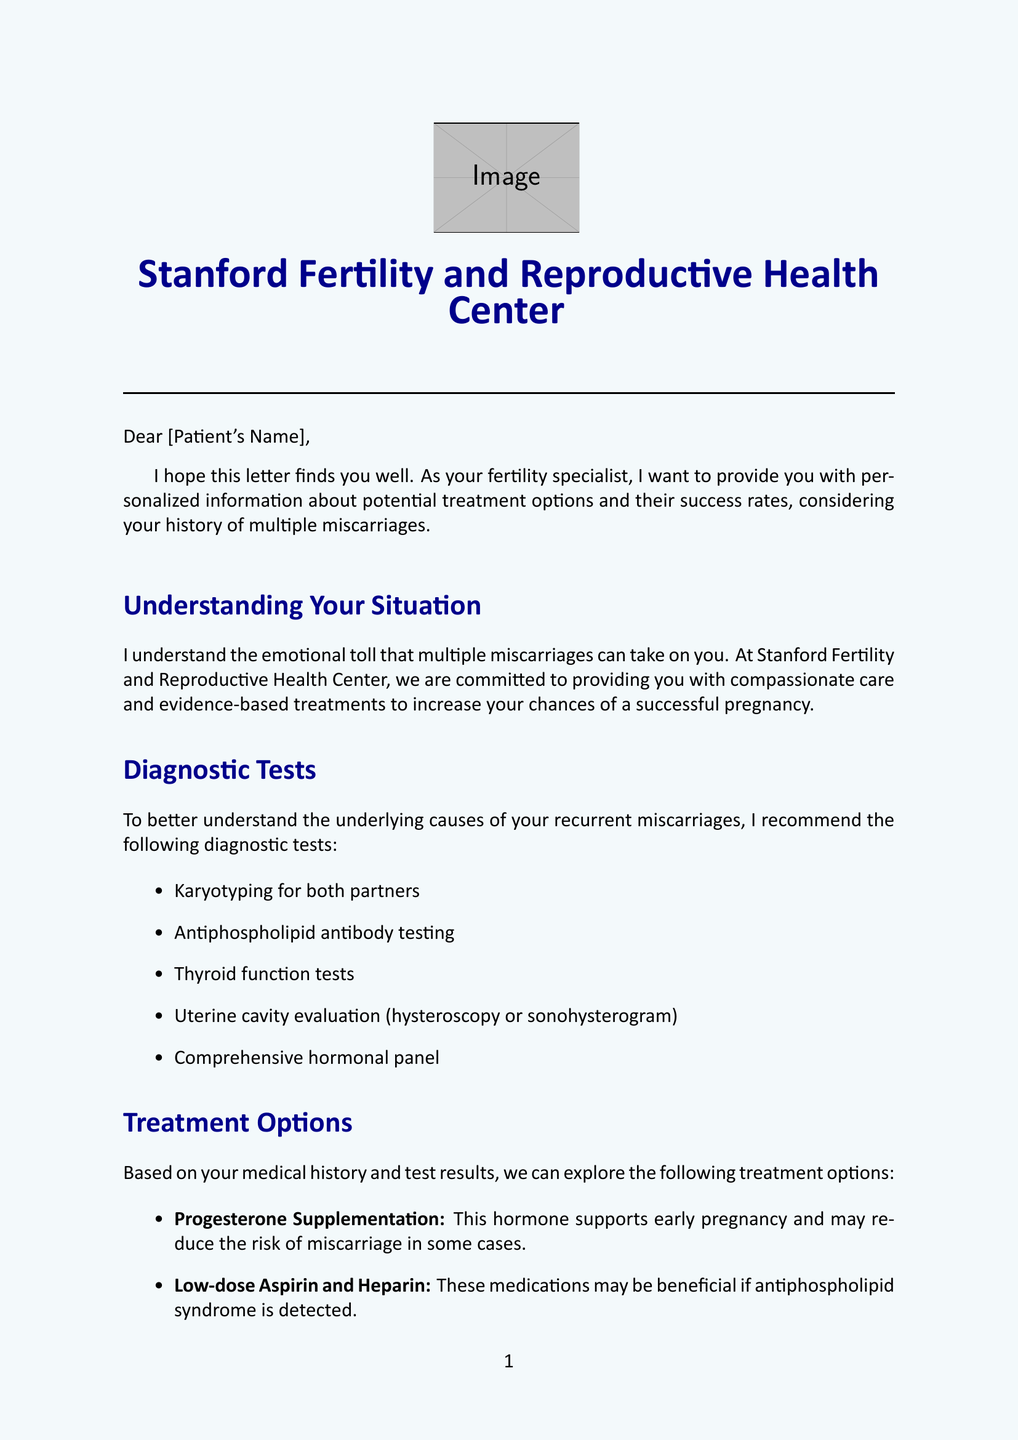what is the name of the clinic? The name of the clinic is mentioned in the letter heading and the closing.
Answer: Stanford Fertility and Reproductive Health Center who is the specialist writing the letter? The name of the specialist is mentioned in the closing of the letter.
Answer: Dr. [Specialist's Name] what is the recommended test for both partners? The letter lists various diagnostic tests and mentions this specific test for both partners.
Answer: Karyotyping what medication may reduce the risk of miscarriage? The letter details a specific hormone that supports early pregnancy.
Answer: Progesterone Supplementation what percentage increase in live birth rates does progesterone supplementation provide? The letter states the increase in live birth rates associated with this treatment.
Answer: 5-10% which service is provided for emotional support? The letter highlights various resources available for emotional support throughout the treatment journey.
Answer: RESOLVE support groups how many patients with recurrent miscarriage successfully get pregnant with appropriate treatment? The document provides a statistic about success rates for women with recurrent miscarriage.
Answer: 65-75% what is suggested as the next step in the process? The letter outlines the next course of action for the patient.
Answer: Schedule a follow-up appointment who specializes in fertility-related stress management? The letter mentions the psychologist who provides specialized support.
Answer: Dr. Emily Chen 